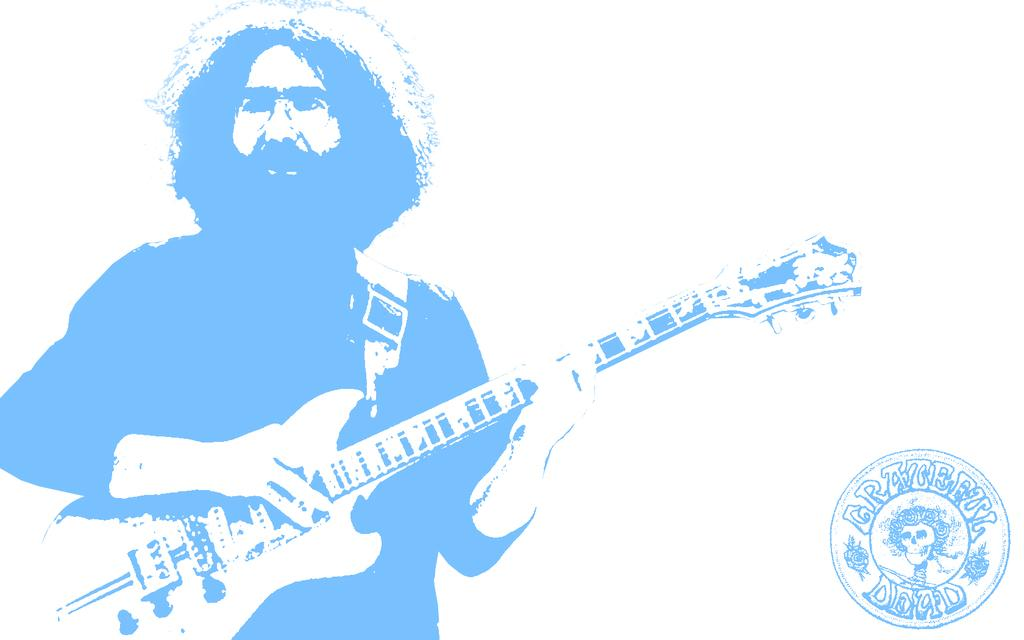What is the main subject of the image? There is a person in the image. What is the person doing in the image? The person is standing and holding a guitar. Can you describe any additional objects in the image? There is a stamp with some text in the image. How many robins can be seen perched on the guitar in the image? There are no robins present in the image, so it is not possible to determine how many would be perched on the guitar. 